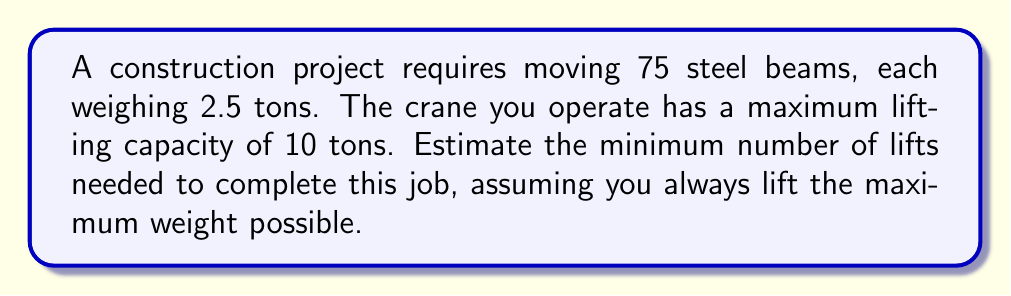What is the answer to this math problem? Let's approach this step-by-step:

1) First, calculate the total weight of all steel beams:
   $$ \text{Total weight} = 75 \text{ beams} \times 2.5 \text{ tons/beam} = 187.5 \text{ tons} $$

2) The crane's maximum capacity is 10 tons per lift. To find the number of lifts, we need to divide the total weight by the crane's capacity:
   $$ \text{Number of lifts} = \frac{\text{Total weight}}{\text{Crane capacity}} $$

3) Substituting the values:
   $$ \text{Number of lifts} = \frac{187.5 \text{ tons}}{10 \text{ tons/lift}} = 18.75 \text{ lifts} $$

4) Since we can't do a partial lift, we need to round up to the nearest whole number:
   $$ \text{Minimum number of lifts} = \lceil 18.75 \rceil = 19 \text{ lifts} $$

Therefore, you would need a minimum of 19 lifts to move all the steel beams.
Answer: 19 lifts 